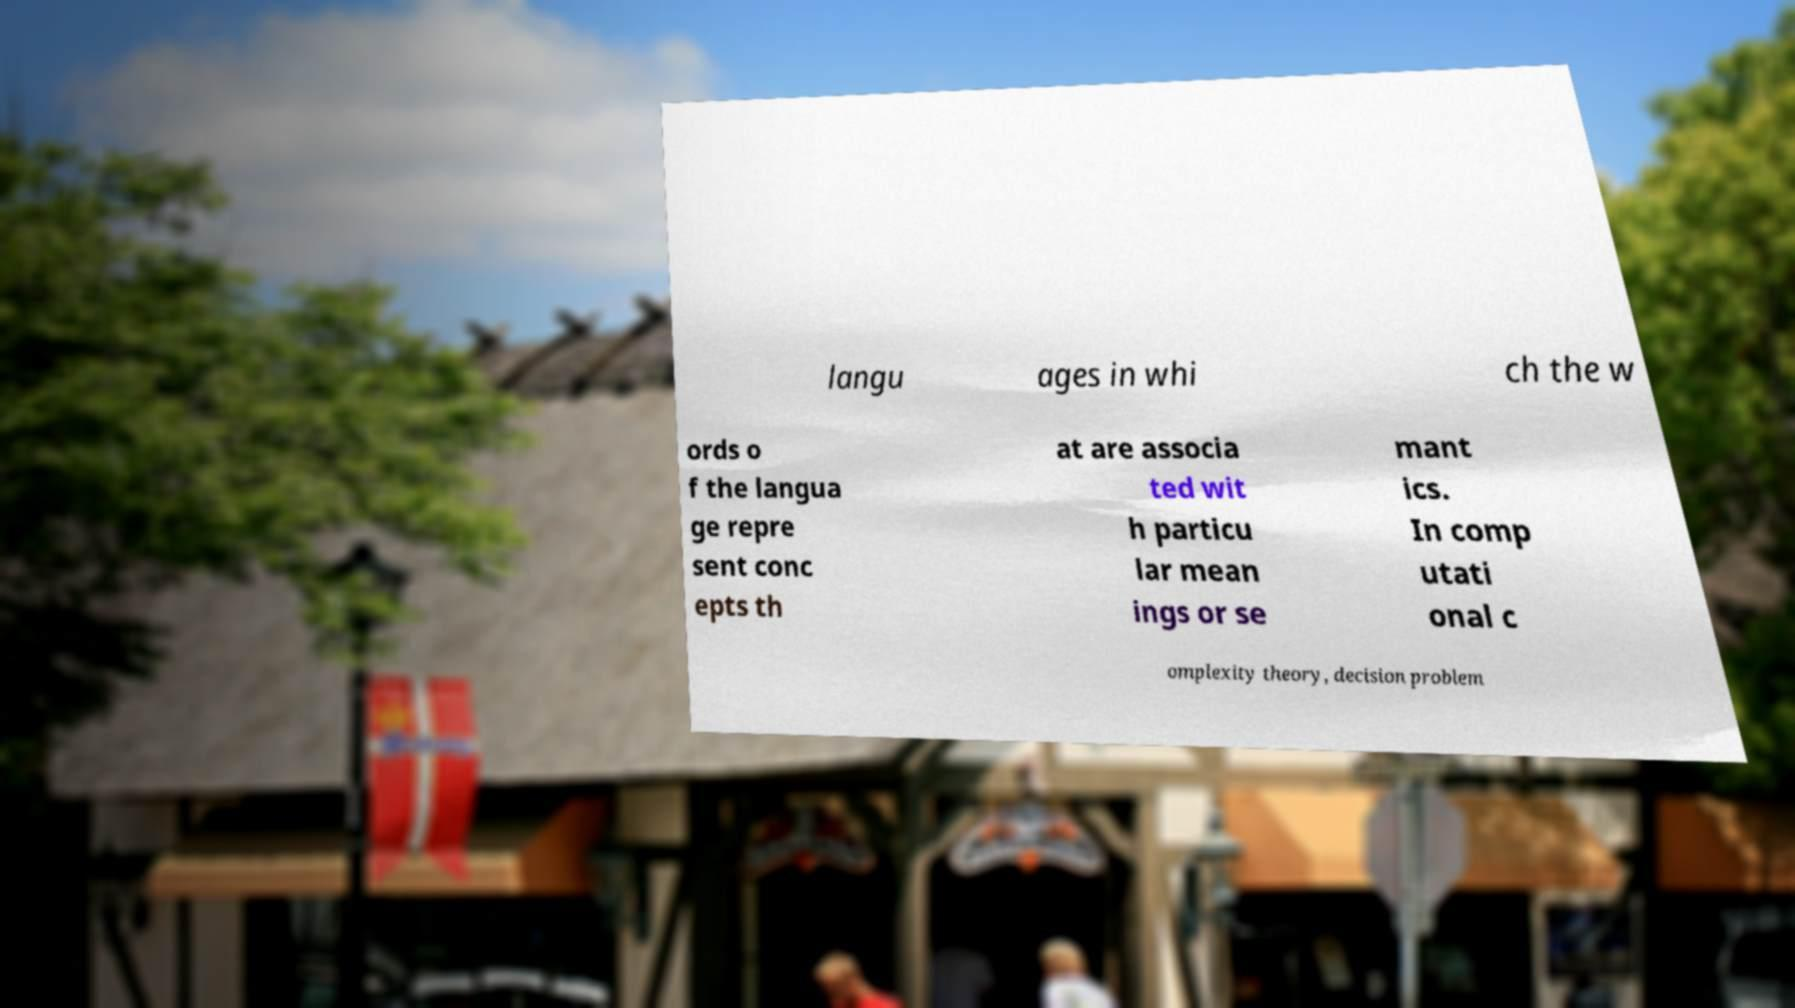Please read and relay the text visible in this image. What does it say? langu ages in whi ch the w ords o f the langua ge repre sent conc epts th at are associa ted wit h particu lar mean ings or se mant ics. In comp utati onal c omplexity theory, decision problem 